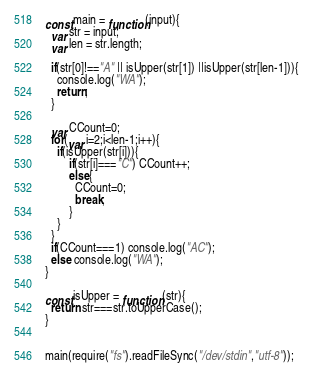<code> <loc_0><loc_0><loc_500><loc_500><_JavaScript_>const main = function(input){
  var str = input;
  var len = str.length;

  if(str[0]!=="A" || isUpper(str[1]) ||isUpper(str[len-1])){
    console.log("WA");
    return;
  }

  var CCount=0;
  for(var i=2;i<len-1;i++){
    if(isUpper(str[i])){
    	if(str[i]==="C") CCount++;
        else{
          CCount=0;
          break;
        }
    }
  }
  if(CCount===1) console.log("AC");
  else console.log("WA");
}

const isUpper = function (str){
  return str===str.toUpperCase();
}
 
 
main(require("fs").readFileSync("/dev/stdin","utf-8"));</code> 